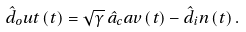<formula> <loc_0><loc_0><loc_500><loc_500>\hat { d } _ { o } u t \left ( t \right ) = \sqrt { \gamma } \, \hat { a } _ { c } a v \left ( t \right ) - \hat { d } _ { i } n \left ( t \right ) .</formula> 